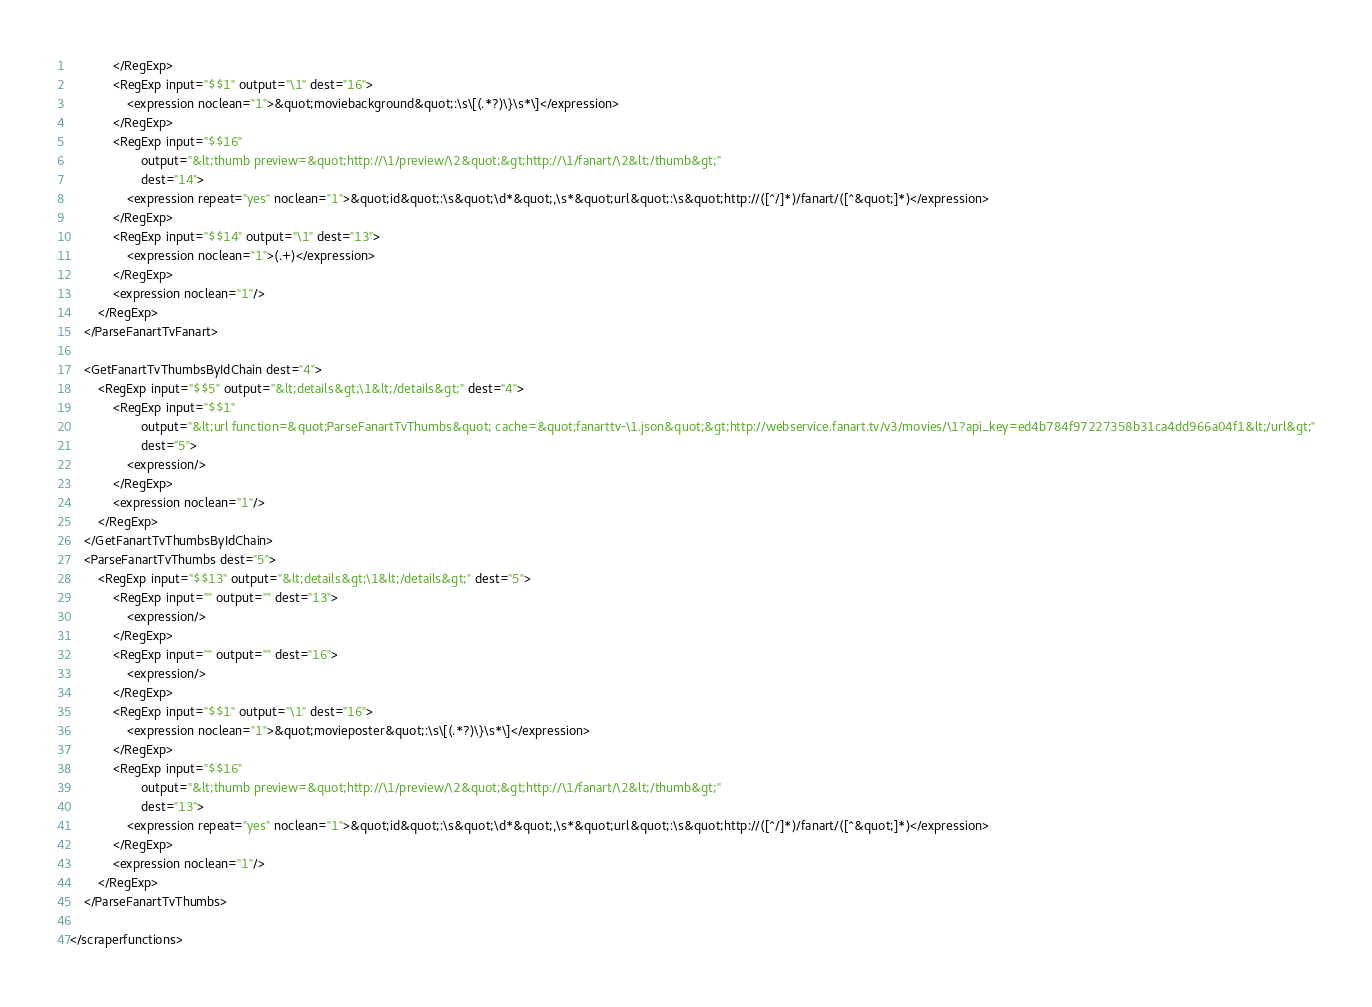Convert code to text. <code><loc_0><loc_0><loc_500><loc_500><_XML_>            </RegExp>
            <RegExp input="$$1" output="\1" dest="16">
                <expression noclean="1">&quot;moviebackground&quot;:\s\[(.*?)\}\s*\]</expression>
            </RegExp>
            <RegExp input="$$16"
                    output="&lt;thumb preview=&quot;http://\1/preview/\2&quot;&gt;http://\1/fanart/\2&lt;/thumb&gt;"
                    dest="14">
                <expression repeat="yes" noclean="1">&quot;id&quot;:\s&quot;\d*&quot;,\s*&quot;url&quot;:\s&quot;http://([^/]*)/fanart/([^&quot;]*)</expression>
            </RegExp>
            <RegExp input="$$14" output="\1" dest="13">
                <expression noclean="1">(.+)</expression>
            </RegExp>
            <expression noclean="1"/>
        </RegExp>
    </ParseFanartTvFanart>

    <GetFanartTvThumbsByIdChain dest="4">
        <RegExp input="$$5" output="&lt;details&gt;\1&lt;/details&gt;" dest="4">
            <RegExp input="$$1"
                    output="&lt;url function=&quot;ParseFanartTvThumbs&quot; cache=&quot;fanarttv-\1.json&quot;&gt;http://webservice.fanart.tv/v3/movies/\1?api_key=ed4b784f97227358b31ca4dd966a04f1&lt;/url&gt;"
                    dest="5">
                <expression/>
            </RegExp>
            <expression noclean="1"/>
        </RegExp>
    </GetFanartTvThumbsByIdChain>
    <ParseFanartTvThumbs dest="5">
        <RegExp input="$$13" output="&lt;details&gt;\1&lt;/details&gt;" dest="5">
            <RegExp input="" output="" dest="13">
                <expression/>
            </RegExp>
            <RegExp input="" output="" dest="16">
                <expression/>
            </RegExp>
            <RegExp input="$$1" output="\1" dest="16">
                <expression noclean="1">&quot;movieposter&quot;:\s\[(.*?)\}\s*\]</expression>
            </RegExp>
            <RegExp input="$$16"
                    output="&lt;thumb preview=&quot;http://\1/preview/\2&quot;&gt;http://\1/fanart/\2&lt;/thumb&gt;"
                    dest="13">
                <expression repeat="yes" noclean="1">&quot;id&quot;:\s&quot;\d*&quot;,\s*&quot;url&quot;:\s&quot;http://([^/]*)/fanart/([^&quot;]*)</expression>
            </RegExp>
            <expression noclean="1"/>
        </RegExp>
    </ParseFanartTvThumbs>

</scraperfunctions>
</code> 